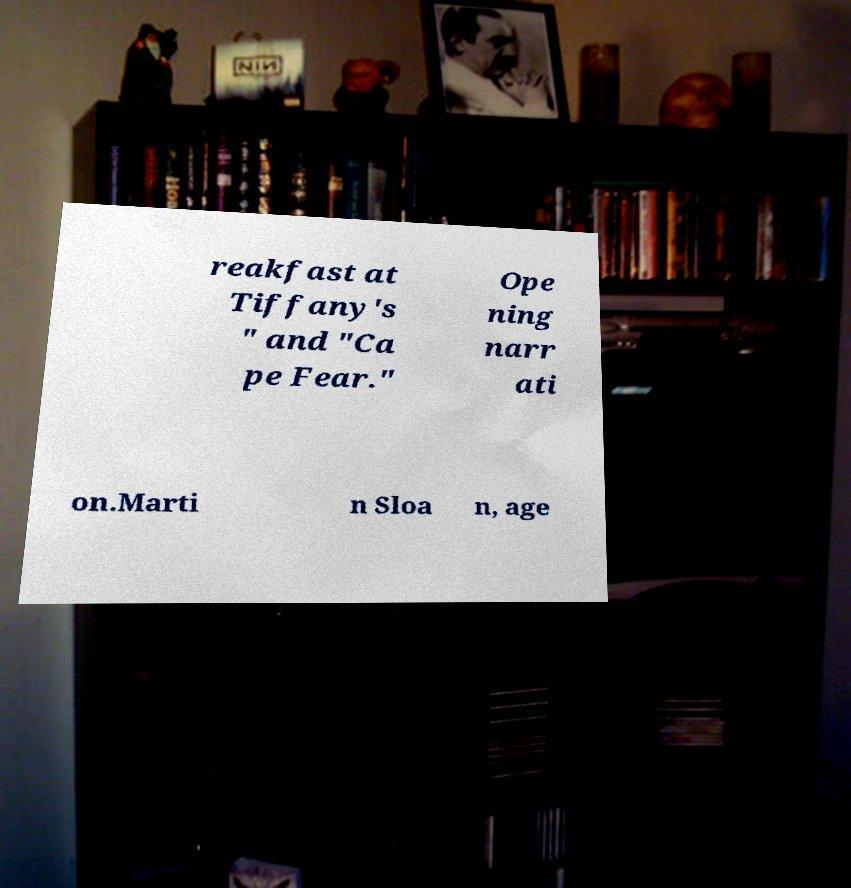For documentation purposes, I need the text within this image transcribed. Could you provide that? reakfast at Tiffany's " and "Ca pe Fear." Ope ning narr ati on.Marti n Sloa n, age 